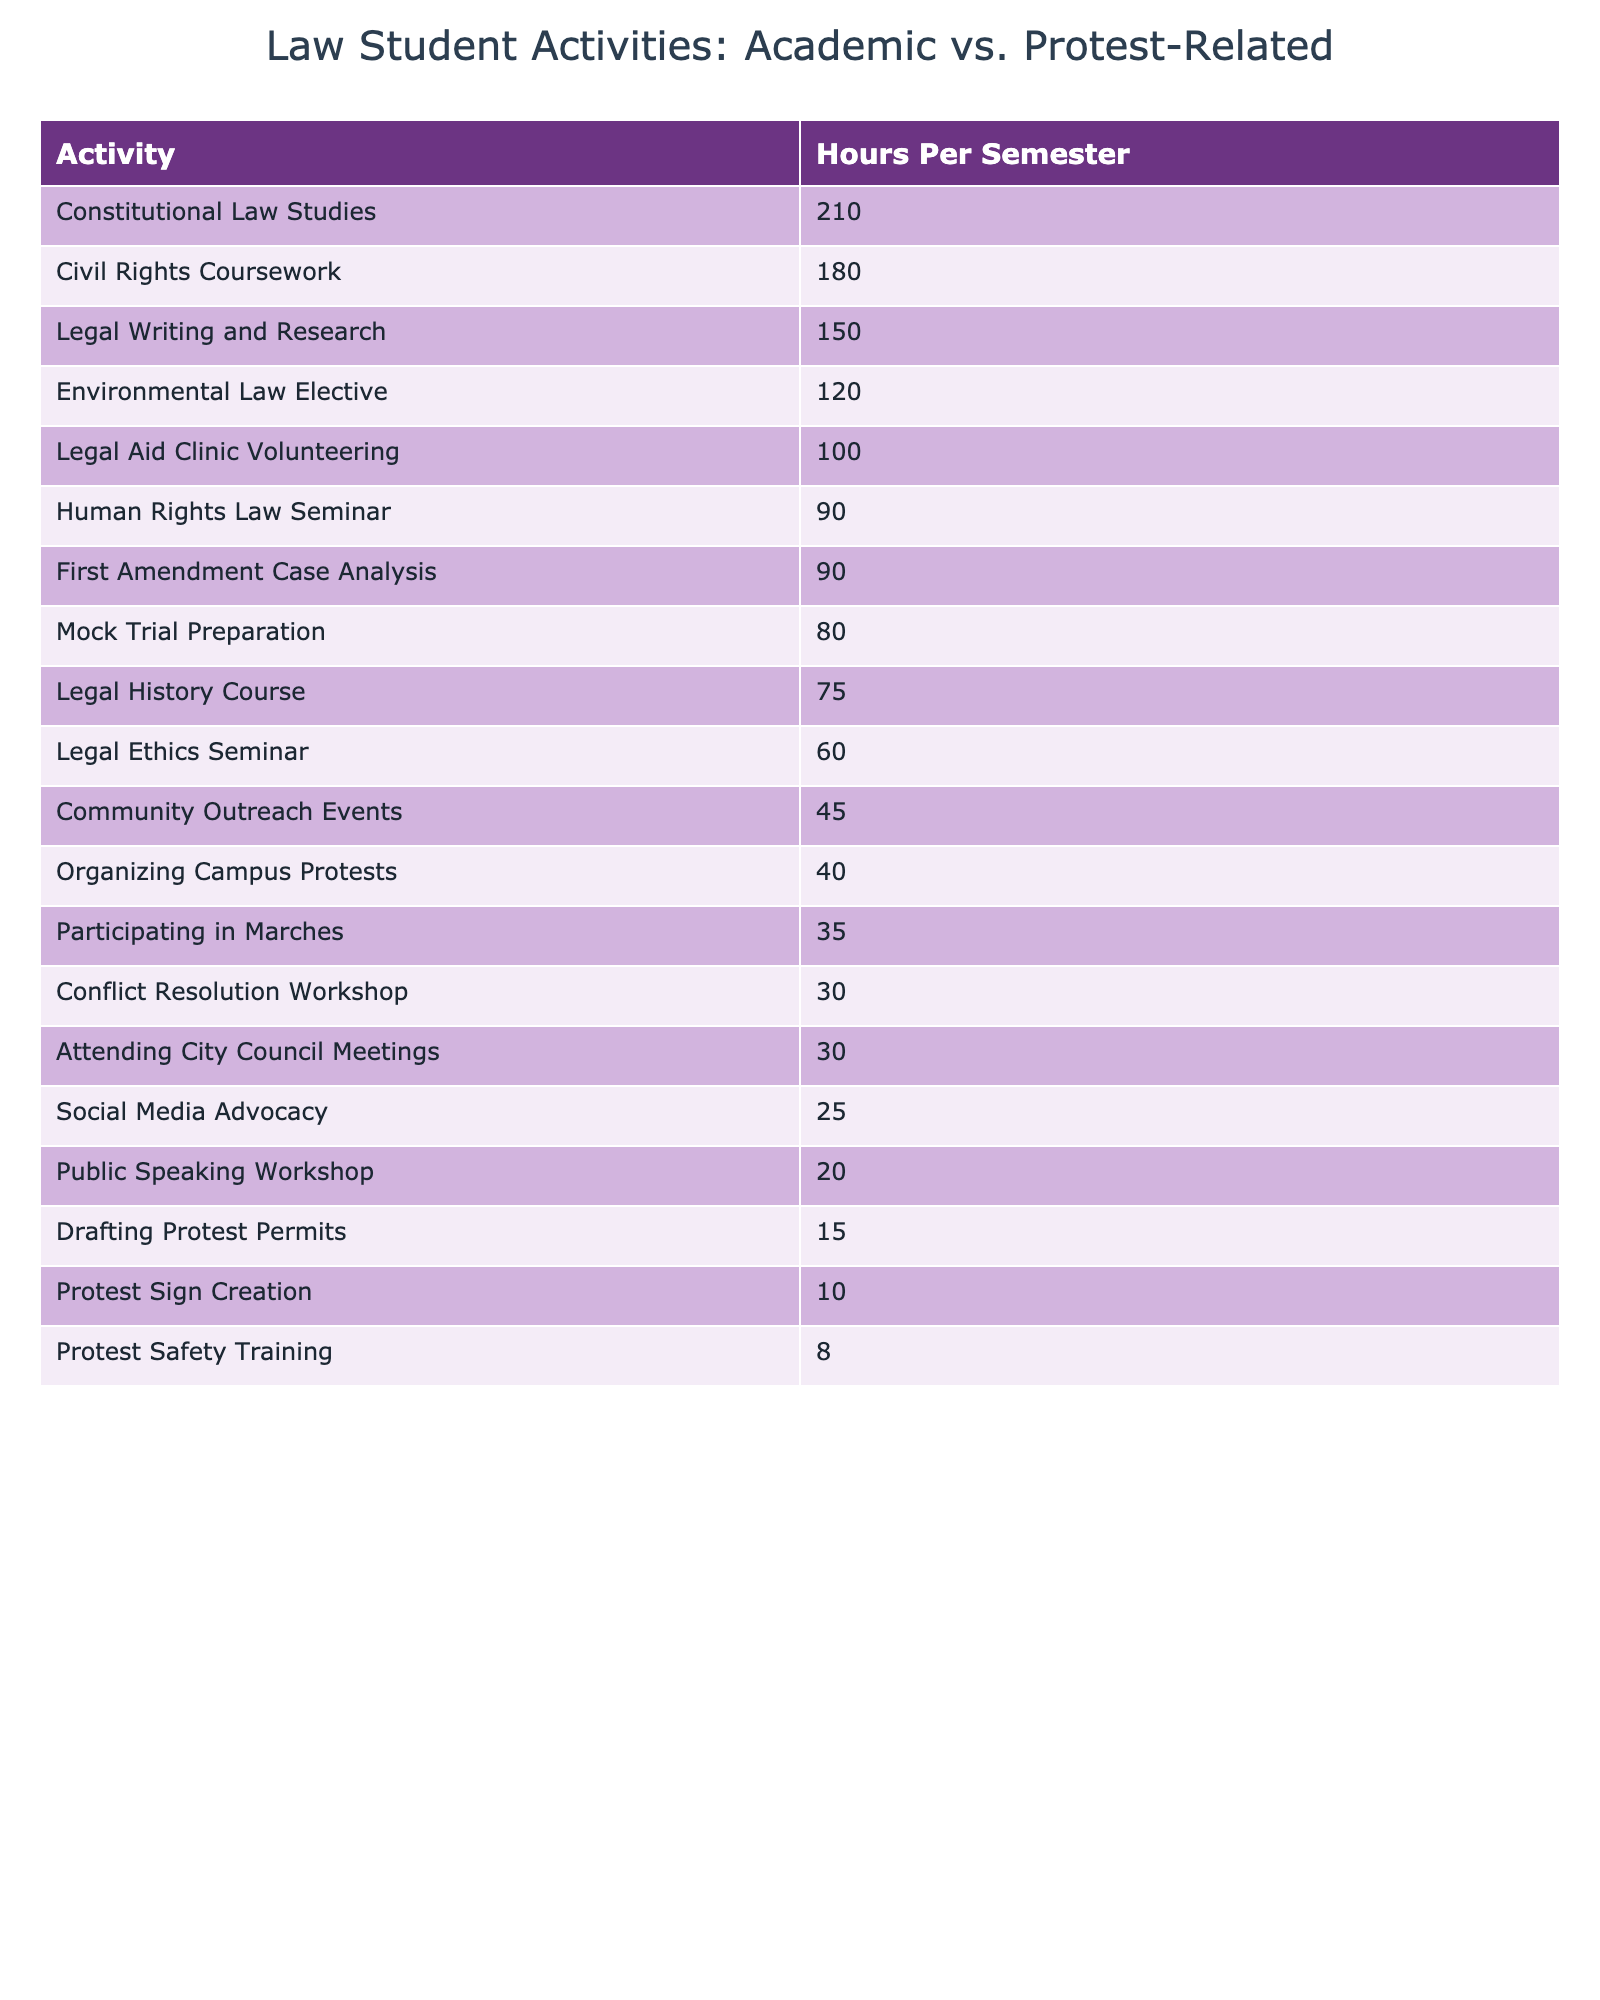What is the total number of hours law students spend on protest-related activities? To find the total hours spent on protest-related activities, I will sum the hours for "Organizing Campus Protests," "Attending City Council Meetings," "Drafting Protest Permits," "Social Media Advocacy," "Protest Sign Creation," "Participating in Marches," and "Protest Safety Training." The calculation is 40 + 30 + 15 + 25 + 10 + 35 + 8 = 163 hours.
Answer: 163 Which academic activity requires the most hours per semester? The activity with the highest hours is "Constitutional Law Studies," which has 210 hours, as indicated by the sorted table.
Answer: Constitutional Law Studies How many more hours are spent on Constitutional Law Studies compared to drafting protest permits? The hours for "Constitutional Law Studies" are 210 and for "Drafting Protest Permits" are 15. The difference is 210 - 15 = 195 hours.
Answer: 195 Is the total hours spent on legal academic activities greater than the total hours spent on protest-related activities? I will sum the hours of all academic activities: 210 (Constitutional Law Studies) + 180 (Civil Rights Coursework) + 150 (Legal Writing and Research) + 60 (Legal Ethics Seminar) + 120 (Environmental Law Elective) + 100 (Legal Aid Clinic Volunteering) + 80 (Mock Trial Preparation) + 90 (Human Rights Law Seminar) + 75 (Legal History Course) + 45 (Community Outreach Events) + 30 (Conflict Resolution Workshop) = 1,140. The total for protest activities is 163. Since 1,140 is greater than 163, the answer is yes.
Answer: Yes What is the average number of hours spent on social media advocacy and protest sign creation combined? The hours for "Social Media Advocacy" is 25 and for "Protest Sign Creation" is 10. Adding these gives 25 + 10 = 35. To find the average, divide by 2: 35 / 2 = 17.5 hours.
Answer: 17.5 Which activity has the least number of hours spent, and what is that number? The activity with the least hours is "Protest Safety Training," with 8 hours, as seen in the table.
Answer: 8 How many more hours are dedicated to Civil Rights Coursework compared to attending City Council Meetings? "Civil Rights Coursework" has 180 hours, while "Attending City Council Meetings" has 30 hours. The difference is 180 - 30 = 150 hours.
Answer: 150 If we combine the hours spent on legal writing and research with those on mock trial preparation, what is the total? The hours for "Legal Writing and Research" are 150 and for "Mock Trial Preparation" are 80. Adding these together gives 150 + 80 = 230 hours.
Answer: 230 What percentage of the total academic hours are devoted to Legal Aid Clinic Volunteering? The total academic hours are 1,140 as calculated earlier. Legal Aid Clinic Volunteering has 100 hours. To find the percentage, calculate (100 / 1,140) * 100 = approximately 8.77%.
Answer: 8.77% How does the time spent on attending city council meetings compare to protest safety training? "Attending City Council Meetings" has 30 hours, while "Protest Safety Training" has 8 hours. The difference is 30 - 8 = 22 hours more for attending city council meetings.
Answer: 22 hours more 